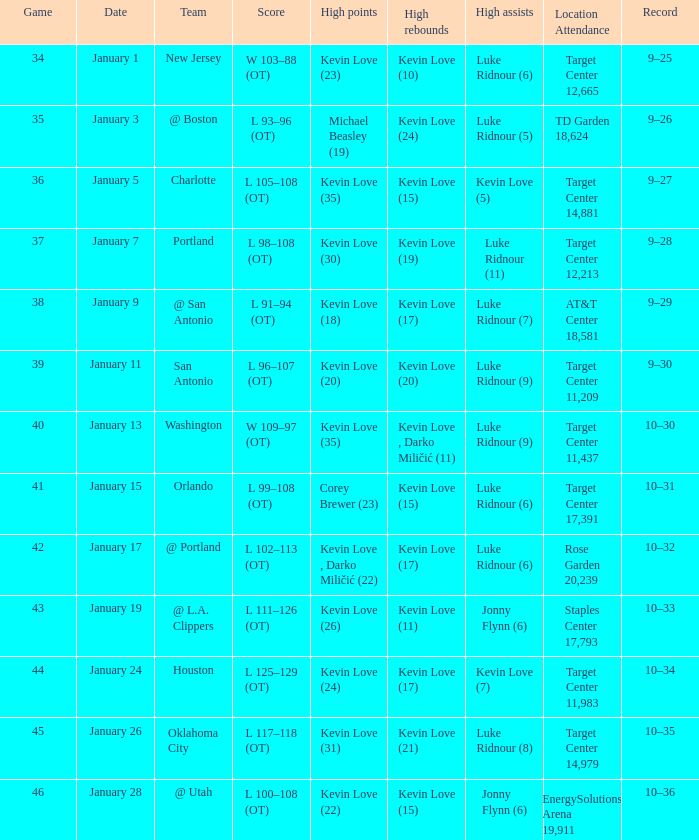What is the date for the game 35? January 3. 